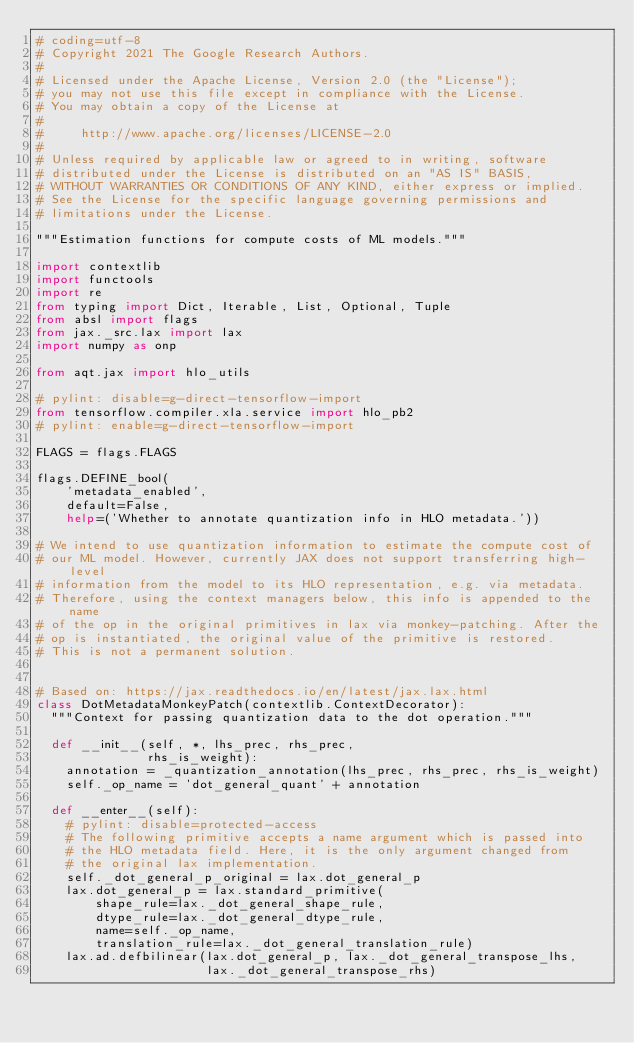Convert code to text. <code><loc_0><loc_0><loc_500><loc_500><_Python_># coding=utf-8
# Copyright 2021 The Google Research Authors.
#
# Licensed under the Apache License, Version 2.0 (the "License");
# you may not use this file except in compliance with the License.
# You may obtain a copy of the License at
#
#     http://www.apache.org/licenses/LICENSE-2.0
#
# Unless required by applicable law or agreed to in writing, software
# distributed under the License is distributed on an "AS IS" BASIS,
# WITHOUT WARRANTIES OR CONDITIONS OF ANY KIND, either express or implied.
# See the License for the specific language governing permissions and
# limitations under the License.

"""Estimation functions for compute costs of ML models."""

import contextlib
import functools
import re
from typing import Dict, Iterable, List, Optional, Tuple
from absl import flags
from jax._src.lax import lax
import numpy as onp

from aqt.jax import hlo_utils

# pylint: disable=g-direct-tensorflow-import
from tensorflow.compiler.xla.service import hlo_pb2
# pylint: enable=g-direct-tensorflow-import

FLAGS = flags.FLAGS

flags.DEFINE_bool(
    'metadata_enabled',
    default=False,
    help=('Whether to annotate quantization info in HLO metadata.'))

# We intend to use quantization information to estimate the compute cost of
# our ML model. However, currently JAX does not support transferring high-level
# information from the model to its HLO representation, e.g. via metadata.
# Therefore, using the context managers below, this info is appended to the name
# of the op in the original primitives in lax via monkey-patching. After the
# op is instantiated, the original value of the primitive is restored.
# This is not a permanent solution.


# Based on: https://jax.readthedocs.io/en/latest/jax.lax.html
class DotMetadataMonkeyPatch(contextlib.ContextDecorator):
  """Context for passing quantization data to the dot operation."""

  def __init__(self, *, lhs_prec, rhs_prec,
               rhs_is_weight):
    annotation = _quantization_annotation(lhs_prec, rhs_prec, rhs_is_weight)
    self._op_name = 'dot_general_quant' + annotation

  def __enter__(self):
    # pylint: disable=protected-access
    # The following primitive accepts a name argument which is passed into
    # the HLO metadata field. Here, it is the only argument changed from
    # the original lax implementation.
    self._dot_general_p_original = lax.dot_general_p
    lax.dot_general_p = lax.standard_primitive(
        shape_rule=lax._dot_general_shape_rule,
        dtype_rule=lax._dot_general_dtype_rule,
        name=self._op_name,
        translation_rule=lax._dot_general_translation_rule)
    lax.ad.defbilinear(lax.dot_general_p, lax._dot_general_transpose_lhs,
                       lax._dot_general_transpose_rhs)</code> 